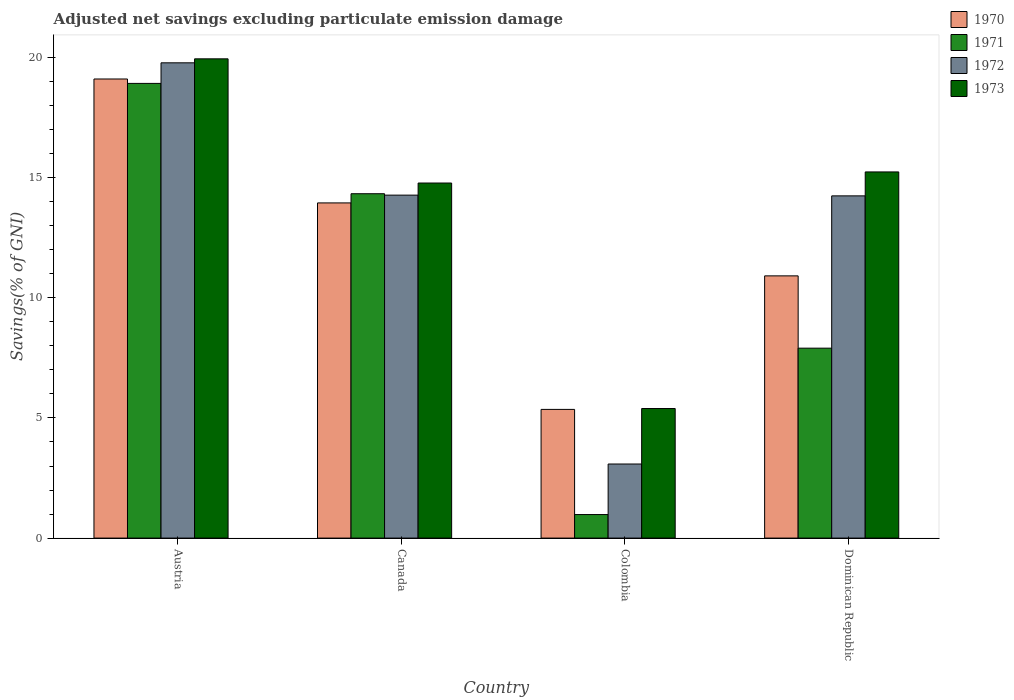How many different coloured bars are there?
Your answer should be compact. 4. How many bars are there on the 1st tick from the left?
Ensure brevity in your answer.  4. In how many cases, is the number of bars for a given country not equal to the number of legend labels?
Your answer should be compact. 0. What is the adjusted net savings in 1971 in Austria?
Your response must be concise. 18.92. Across all countries, what is the maximum adjusted net savings in 1973?
Give a very brief answer. 19.94. Across all countries, what is the minimum adjusted net savings in 1972?
Offer a very short reply. 3.08. In which country was the adjusted net savings in 1972 maximum?
Offer a terse response. Austria. In which country was the adjusted net savings in 1971 minimum?
Offer a very short reply. Colombia. What is the total adjusted net savings in 1971 in the graph?
Your answer should be very brief. 42.14. What is the difference between the adjusted net savings in 1971 in Austria and that in Colombia?
Ensure brevity in your answer.  17.94. What is the difference between the adjusted net savings in 1970 in Canada and the adjusted net savings in 1973 in Dominican Republic?
Provide a short and direct response. -1.29. What is the average adjusted net savings in 1971 per country?
Provide a short and direct response. 10.53. What is the difference between the adjusted net savings of/in 1971 and adjusted net savings of/in 1973 in Canada?
Provide a succinct answer. -0.45. What is the ratio of the adjusted net savings in 1972 in Canada to that in Dominican Republic?
Give a very brief answer. 1. What is the difference between the highest and the second highest adjusted net savings in 1973?
Your response must be concise. 5.17. What is the difference between the highest and the lowest adjusted net savings in 1970?
Offer a terse response. 13.75. In how many countries, is the adjusted net savings in 1971 greater than the average adjusted net savings in 1971 taken over all countries?
Give a very brief answer. 2. Is the sum of the adjusted net savings in 1971 in Austria and Dominican Republic greater than the maximum adjusted net savings in 1970 across all countries?
Provide a short and direct response. Yes. Is it the case that in every country, the sum of the adjusted net savings in 1972 and adjusted net savings in 1971 is greater than the adjusted net savings in 1973?
Make the answer very short. No. Are all the bars in the graph horizontal?
Give a very brief answer. No. How many countries are there in the graph?
Your response must be concise. 4. What is the difference between two consecutive major ticks on the Y-axis?
Ensure brevity in your answer.  5. Where does the legend appear in the graph?
Offer a very short reply. Top right. How many legend labels are there?
Keep it short and to the point. 4. What is the title of the graph?
Your response must be concise. Adjusted net savings excluding particulate emission damage. Does "1973" appear as one of the legend labels in the graph?
Make the answer very short. Yes. What is the label or title of the Y-axis?
Your answer should be compact. Savings(% of GNI). What is the Savings(% of GNI) in 1970 in Austria?
Offer a very short reply. 19.11. What is the Savings(% of GNI) of 1971 in Austria?
Your response must be concise. 18.92. What is the Savings(% of GNI) of 1972 in Austria?
Your answer should be very brief. 19.78. What is the Savings(% of GNI) in 1973 in Austria?
Keep it short and to the point. 19.94. What is the Savings(% of GNI) in 1970 in Canada?
Provide a short and direct response. 13.95. What is the Savings(% of GNI) of 1971 in Canada?
Your answer should be compact. 14.33. What is the Savings(% of GNI) of 1972 in Canada?
Make the answer very short. 14.27. What is the Savings(% of GNI) in 1973 in Canada?
Offer a terse response. 14.78. What is the Savings(% of GNI) in 1970 in Colombia?
Provide a succinct answer. 5.36. What is the Savings(% of GNI) in 1971 in Colombia?
Provide a short and direct response. 0.98. What is the Savings(% of GNI) in 1972 in Colombia?
Give a very brief answer. 3.08. What is the Savings(% of GNI) in 1973 in Colombia?
Give a very brief answer. 5.39. What is the Savings(% of GNI) in 1970 in Dominican Republic?
Keep it short and to the point. 10.91. What is the Savings(% of GNI) of 1971 in Dominican Republic?
Make the answer very short. 7.9. What is the Savings(% of GNI) of 1972 in Dominican Republic?
Make the answer very short. 14.24. What is the Savings(% of GNI) of 1973 in Dominican Republic?
Your response must be concise. 15.24. Across all countries, what is the maximum Savings(% of GNI) of 1970?
Give a very brief answer. 19.11. Across all countries, what is the maximum Savings(% of GNI) in 1971?
Keep it short and to the point. 18.92. Across all countries, what is the maximum Savings(% of GNI) of 1972?
Make the answer very short. 19.78. Across all countries, what is the maximum Savings(% of GNI) of 1973?
Your answer should be very brief. 19.94. Across all countries, what is the minimum Savings(% of GNI) of 1970?
Keep it short and to the point. 5.36. Across all countries, what is the minimum Savings(% of GNI) in 1971?
Keep it short and to the point. 0.98. Across all countries, what is the minimum Savings(% of GNI) in 1972?
Your answer should be compact. 3.08. Across all countries, what is the minimum Savings(% of GNI) of 1973?
Offer a very short reply. 5.39. What is the total Savings(% of GNI) in 1970 in the graph?
Your answer should be very brief. 49.32. What is the total Savings(% of GNI) of 1971 in the graph?
Offer a very short reply. 42.14. What is the total Savings(% of GNI) of 1972 in the graph?
Ensure brevity in your answer.  51.38. What is the total Savings(% of GNI) of 1973 in the graph?
Your answer should be very brief. 55.35. What is the difference between the Savings(% of GNI) in 1970 in Austria and that in Canada?
Offer a very short reply. 5.16. What is the difference between the Savings(% of GNI) in 1971 in Austria and that in Canada?
Keep it short and to the point. 4.59. What is the difference between the Savings(% of GNI) in 1972 in Austria and that in Canada?
Ensure brevity in your answer.  5.51. What is the difference between the Savings(% of GNI) in 1973 in Austria and that in Canada?
Keep it short and to the point. 5.17. What is the difference between the Savings(% of GNI) of 1970 in Austria and that in Colombia?
Provide a short and direct response. 13.75. What is the difference between the Savings(% of GNI) of 1971 in Austria and that in Colombia?
Your response must be concise. 17.94. What is the difference between the Savings(% of GNI) of 1972 in Austria and that in Colombia?
Provide a short and direct response. 16.7. What is the difference between the Savings(% of GNI) in 1973 in Austria and that in Colombia?
Keep it short and to the point. 14.55. What is the difference between the Savings(% of GNI) in 1970 in Austria and that in Dominican Republic?
Your answer should be compact. 8.19. What is the difference between the Savings(% of GNI) in 1971 in Austria and that in Dominican Republic?
Ensure brevity in your answer.  11.02. What is the difference between the Savings(% of GNI) of 1972 in Austria and that in Dominican Republic?
Your answer should be very brief. 5.54. What is the difference between the Savings(% of GNI) of 1973 in Austria and that in Dominican Republic?
Offer a very short reply. 4.71. What is the difference between the Savings(% of GNI) in 1970 in Canada and that in Colombia?
Your answer should be compact. 8.59. What is the difference between the Savings(% of GNI) of 1971 in Canada and that in Colombia?
Your answer should be very brief. 13.35. What is the difference between the Savings(% of GNI) of 1972 in Canada and that in Colombia?
Provide a short and direct response. 11.19. What is the difference between the Savings(% of GNI) of 1973 in Canada and that in Colombia?
Offer a terse response. 9.38. What is the difference between the Savings(% of GNI) of 1970 in Canada and that in Dominican Republic?
Make the answer very short. 3.04. What is the difference between the Savings(% of GNI) in 1971 in Canada and that in Dominican Republic?
Ensure brevity in your answer.  6.43. What is the difference between the Savings(% of GNI) in 1972 in Canada and that in Dominican Republic?
Make the answer very short. 0.03. What is the difference between the Savings(% of GNI) of 1973 in Canada and that in Dominican Republic?
Your response must be concise. -0.46. What is the difference between the Savings(% of GNI) of 1970 in Colombia and that in Dominican Republic?
Keep it short and to the point. -5.56. What is the difference between the Savings(% of GNI) in 1971 in Colombia and that in Dominican Republic?
Make the answer very short. -6.92. What is the difference between the Savings(% of GNI) in 1972 in Colombia and that in Dominican Republic?
Keep it short and to the point. -11.16. What is the difference between the Savings(% of GNI) of 1973 in Colombia and that in Dominican Republic?
Keep it short and to the point. -9.85. What is the difference between the Savings(% of GNI) of 1970 in Austria and the Savings(% of GNI) of 1971 in Canada?
Provide a short and direct response. 4.77. What is the difference between the Savings(% of GNI) in 1970 in Austria and the Savings(% of GNI) in 1972 in Canada?
Ensure brevity in your answer.  4.83. What is the difference between the Savings(% of GNI) of 1970 in Austria and the Savings(% of GNI) of 1973 in Canada?
Provide a succinct answer. 4.33. What is the difference between the Savings(% of GNI) in 1971 in Austria and the Savings(% of GNI) in 1972 in Canada?
Keep it short and to the point. 4.65. What is the difference between the Savings(% of GNI) in 1971 in Austria and the Savings(% of GNI) in 1973 in Canada?
Offer a terse response. 4.15. What is the difference between the Savings(% of GNI) of 1972 in Austria and the Savings(% of GNI) of 1973 in Canada?
Make the answer very short. 5. What is the difference between the Savings(% of GNI) of 1970 in Austria and the Savings(% of GNI) of 1971 in Colombia?
Ensure brevity in your answer.  18.13. What is the difference between the Savings(% of GNI) of 1970 in Austria and the Savings(% of GNI) of 1972 in Colombia?
Make the answer very short. 16.02. What is the difference between the Savings(% of GNI) of 1970 in Austria and the Savings(% of GNI) of 1973 in Colombia?
Provide a succinct answer. 13.71. What is the difference between the Savings(% of GNI) of 1971 in Austria and the Savings(% of GNI) of 1972 in Colombia?
Keep it short and to the point. 15.84. What is the difference between the Savings(% of GNI) in 1971 in Austria and the Savings(% of GNI) in 1973 in Colombia?
Offer a terse response. 13.53. What is the difference between the Savings(% of GNI) in 1972 in Austria and the Savings(% of GNI) in 1973 in Colombia?
Your response must be concise. 14.39. What is the difference between the Savings(% of GNI) in 1970 in Austria and the Savings(% of GNI) in 1971 in Dominican Republic?
Make the answer very short. 11.2. What is the difference between the Savings(% of GNI) in 1970 in Austria and the Savings(% of GNI) in 1972 in Dominican Republic?
Give a very brief answer. 4.86. What is the difference between the Savings(% of GNI) in 1970 in Austria and the Savings(% of GNI) in 1973 in Dominican Republic?
Make the answer very short. 3.87. What is the difference between the Savings(% of GNI) of 1971 in Austria and the Savings(% of GNI) of 1972 in Dominican Republic?
Your answer should be compact. 4.68. What is the difference between the Savings(% of GNI) in 1971 in Austria and the Savings(% of GNI) in 1973 in Dominican Republic?
Give a very brief answer. 3.68. What is the difference between the Savings(% of GNI) of 1972 in Austria and the Savings(% of GNI) of 1973 in Dominican Republic?
Your answer should be compact. 4.54. What is the difference between the Savings(% of GNI) of 1970 in Canada and the Savings(% of GNI) of 1971 in Colombia?
Your response must be concise. 12.97. What is the difference between the Savings(% of GNI) of 1970 in Canada and the Savings(% of GNI) of 1972 in Colombia?
Offer a very short reply. 10.87. What is the difference between the Savings(% of GNI) in 1970 in Canada and the Savings(% of GNI) in 1973 in Colombia?
Ensure brevity in your answer.  8.56. What is the difference between the Savings(% of GNI) in 1971 in Canada and the Savings(% of GNI) in 1972 in Colombia?
Your answer should be compact. 11.25. What is the difference between the Savings(% of GNI) in 1971 in Canada and the Savings(% of GNI) in 1973 in Colombia?
Ensure brevity in your answer.  8.94. What is the difference between the Savings(% of GNI) of 1972 in Canada and the Savings(% of GNI) of 1973 in Colombia?
Give a very brief answer. 8.88. What is the difference between the Savings(% of GNI) in 1970 in Canada and the Savings(% of GNI) in 1971 in Dominican Republic?
Provide a short and direct response. 6.05. What is the difference between the Savings(% of GNI) of 1970 in Canada and the Savings(% of GNI) of 1972 in Dominican Republic?
Ensure brevity in your answer.  -0.29. What is the difference between the Savings(% of GNI) of 1970 in Canada and the Savings(% of GNI) of 1973 in Dominican Republic?
Your answer should be compact. -1.29. What is the difference between the Savings(% of GNI) in 1971 in Canada and the Savings(% of GNI) in 1972 in Dominican Republic?
Your response must be concise. 0.09. What is the difference between the Savings(% of GNI) of 1971 in Canada and the Savings(% of GNI) of 1973 in Dominican Republic?
Provide a short and direct response. -0.91. What is the difference between the Savings(% of GNI) of 1972 in Canada and the Savings(% of GNI) of 1973 in Dominican Republic?
Your answer should be compact. -0.97. What is the difference between the Savings(% of GNI) of 1970 in Colombia and the Savings(% of GNI) of 1971 in Dominican Republic?
Your response must be concise. -2.55. What is the difference between the Savings(% of GNI) in 1970 in Colombia and the Savings(% of GNI) in 1972 in Dominican Republic?
Provide a short and direct response. -8.89. What is the difference between the Savings(% of GNI) of 1970 in Colombia and the Savings(% of GNI) of 1973 in Dominican Republic?
Offer a terse response. -9.88. What is the difference between the Savings(% of GNI) of 1971 in Colombia and the Savings(% of GNI) of 1972 in Dominican Republic?
Make the answer very short. -13.26. What is the difference between the Savings(% of GNI) of 1971 in Colombia and the Savings(% of GNI) of 1973 in Dominican Republic?
Keep it short and to the point. -14.26. What is the difference between the Savings(% of GNI) of 1972 in Colombia and the Savings(% of GNI) of 1973 in Dominican Republic?
Keep it short and to the point. -12.15. What is the average Savings(% of GNI) of 1970 per country?
Your answer should be very brief. 12.33. What is the average Savings(% of GNI) in 1971 per country?
Provide a succinct answer. 10.53. What is the average Savings(% of GNI) of 1972 per country?
Ensure brevity in your answer.  12.84. What is the average Savings(% of GNI) of 1973 per country?
Keep it short and to the point. 13.84. What is the difference between the Savings(% of GNI) of 1970 and Savings(% of GNI) of 1971 in Austria?
Make the answer very short. 0.18. What is the difference between the Savings(% of GNI) in 1970 and Savings(% of GNI) in 1972 in Austria?
Offer a very short reply. -0.67. What is the difference between the Savings(% of GNI) in 1970 and Savings(% of GNI) in 1973 in Austria?
Make the answer very short. -0.84. What is the difference between the Savings(% of GNI) of 1971 and Savings(% of GNI) of 1972 in Austria?
Your response must be concise. -0.86. What is the difference between the Savings(% of GNI) in 1971 and Savings(% of GNI) in 1973 in Austria?
Your response must be concise. -1.02. What is the difference between the Savings(% of GNI) of 1972 and Savings(% of GNI) of 1973 in Austria?
Ensure brevity in your answer.  -0.17. What is the difference between the Savings(% of GNI) in 1970 and Savings(% of GNI) in 1971 in Canada?
Give a very brief answer. -0.38. What is the difference between the Savings(% of GNI) of 1970 and Savings(% of GNI) of 1972 in Canada?
Make the answer very short. -0.32. What is the difference between the Savings(% of GNI) of 1970 and Savings(% of GNI) of 1973 in Canada?
Your answer should be compact. -0.83. What is the difference between the Savings(% of GNI) of 1971 and Savings(% of GNI) of 1972 in Canada?
Your answer should be very brief. 0.06. What is the difference between the Savings(% of GNI) in 1971 and Savings(% of GNI) in 1973 in Canada?
Make the answer very short. -0.45. What is the difference between the Savings(% of GNI) of 1972 and Savings(% of GNI) of 1973 in Canada?
Your answer should be compact. -0.5. What is the difference between the Savings(% of GNI) of 1970 and Savings(% of GNI) of 1971 in Colombia?
Give a very brief answer. 4.38. What is the difference between the Savings(% of GNI) of 1970 and Savings(% of GNI) of 1972 in Colombia?
Ensure brevity in your answer.  2.27. What is the difference between the Savings(% of GNI) of 1970 and Savings(% of GNI) of 1973 in Colombia?
Provide a succinct answer. -0.04. What is the difference between the Savings(% of GNI) in 1971 and Savings(% of GNI) in 1972 in Colombia?
Provide a short and direct response. -2.1. What is the difference between the Savings(% of GNI) in 1971 and Savings(% of GNI) in 1973 in Colombia?
Your answer should be very brief. -4.41. What is the difference between the Savings(% of GNI) of 1972 and Savings(% of GNI) of 1973 in Colombia?
Your response must be concise. -2.31. What is the difference between the Savings(% of GNI) in 1970 and Savings(% of GNI) in 1971 in Dominican Republic?
Keep it short and to the point. 3.01. What is the difference between the Savings(% of GNI) in 1970 and Savings(% of GNI) in 1972 in Dominican Republic?
Your answer should be very brief. -3.33. What is the difference between the Savings(% of GNI) in 1970 and Savings(% of GNI) in 1973 in Dominican Republic?
Your answer should be very brief. -4.33. What is the difference between the Savings(% of GNI) in 1971 and Savings(% of GNI) in 1972 in Dominican Republic?
Your response must be concise. -6.34. What is the difference between the Savings(% of GNI) of 1971 and Savings(% of GNI) of 1973 in Dominican Republic?
Your response must be concise. -7.33. What is the difference between the Savings(% of GNI) in 1972 and Savings(% of GNI) in 1973 in Dominican Republic?
Give a very brief answer. -1. What is the ratio of the Savings(% of GNI) in 1970 in Austria to that in Canada?
Provide a succinct answer. 1.37. What is the ratio of the Savings(% of GNI) of 1971 in Austria to that in Canada?
Your answer should be compact. 1.32. What is the ratio of the Savings(% of GNI) of 1972 in Austria to that in Canada?
Provide a succinct answer. 1.39. What is the ratio of the Savings(% of GNI) of 1973 in Austria to that in Canada?
Provide a short and direct response. 1.35. What is the ratio of the Savings(% of GNI) in 1970 in Austria to that in Colombia?
Your response must be concise. 3.57. What is the ratio of the Savings(% of GNI) of 1971 in Austria to that in Colombia?
Make the answer very short. 19.32. What is the ratio of the Savings(% of GNI) in 1972 in Austria to that in Colombia?
Give a very brief answer. 6.42. What is the ratio of the Savings(% of GNI) in 1973 in Austria to that in Colombia?
Offer a terse response. 3.7. What is the ratio of the Savings(% of GNI) of 1970 in Austria to that in Dominican Republic?
Make the answer very short. 1.75. What is the ratio of the Savings(% of GNI) in 1971 in Austria to that in Dominican Republic?
Ensure brevity in your answer.  2.39. What is the ratio of the Savings(% of GNI) in 1972 in Austria to that in Dominican Republic?
Give a very brief answer. 1.39. What is the ratio of the Savings(% of GNI) of 1973 in Austria to that in Dominican Republic?
Provide a short and direct response. 1.31. What is the ratio of the Savings(% of GNI) in 1970 in Canada to that in Colombia?
Give a very brief answer. 2.6. What is the ratio of the Savings(% of GNI) in 1971 in Canada to that in Colombia?
Offer a very short reply. 14.64. What is the ratio of the Savings(% of GNI) in 1972 in Canada to that in Colombia?
Provide a short and direct response. 4.63. What is the ratio of the Savings(% of GNI) in 1973 in Canada to that in Colombia?
Make the answer very short. 2.74. What is the ratio of the Savings(% of GNI) in 1970 in Canada to that in Dominican Republic?
Offer a very short reply. 1.28. What is the ratio of the Savings(% of GNI) in 1971 in Canada to that in Dominican Republic?
Offer a very short reply. 1.81. What is the ratio of the Savings(% of GNI) of 1972 in Canada to that in Dominican Republic?
Make the answer very short. 1. What is the ratio of the Savings(% of GNI) of 1973 in Canada to that in Dominican Republic?
Your response must be concise. 0.97. What is the ratio of the Savings(% of GNI) in 1970 in Colombia to that in Dominican Republic?
Your answer should be compact. 0.49. What is the ratio of the Savings(% of GNI) of 1971 in Colombia to that in Dominican Republic?
Make the answer very short. 0.12. What is the ratio of the Savings(% of GNI) of 1972 in Colombia to that in Dominican Republic?
Provide a short and direct response. 0.22. What is the ratio of the Savings(% of GNI) of 1973 in Colombia to that in Dominican Republic?
Ensure brevity in your answer.  0.35. What is the difference between the highest and the second highest Savings(% of GNI) of 1970?
Keep it short and to the point. 5.16. What is the difference between the highest and the second highest Savings(% of GNI) of 1971?
Make the answer very short. 4.59. What is the difference between the highest and the second highest Savings(% of GNI) of 1972?
Your answer should be compact. 5.51. What is the difference between the highest and the second highest Savings(% of GNI) in 1973?
Your response must be concise. 4.71. What is the difference between the highest and the lowest Savings(% of GNI) of 1970?
Offer a very short reply. 13.75. What is the difference between the highest and the lowest Savings(% of GNI) of 1971?
Provide a short and direct response. 17.94. What is the difference between the highest and the lowest Savings(% of GNI) in 1972?
Make the answer very short. 16.7. What is the difference between the highest and the lowest Savings(% of GNI) of 1973?
Your answer should be very brief. 14.55. 